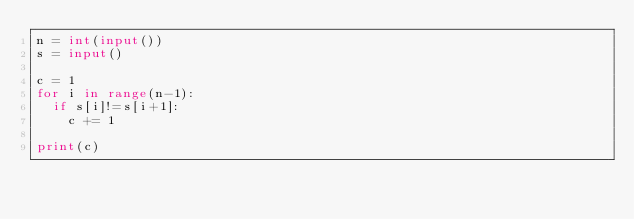Convert code to text. <code><loc_0><loc_0><loc_500><loc_500><_Python_>n = int(input())
s = input()

c = 1
for i in range(n-1):
  if s[i]!=s[i+1]:
    c += 1

print(c)</code> 